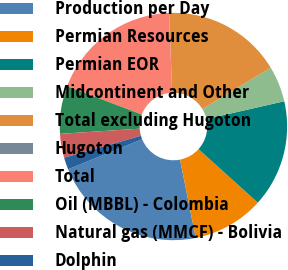<chart> <loc_0><loc_0><loc_500><loc_500><pie_chart><fcel>Production per Day<fcel>Permian Resources<fcel>Permian EOR<fcel>Midcontinent and Other<fcel>Total excluding Hugoton<fcel>Hugoton<fcel>Total<fcel>Oil (MBBL) - Colombia<fcel>Natural gas (MMCF) - Bolivia<fcel>Dolphin<nl><fcel>22.01%<fcel>10.17%<fcel>15.25%<fcel>5.09%<fcel>16.94%<fcel>0.02%<fcel>18.63%<fcel>6.79%<fcel>3.4%<fcel>1.71%<nl></chart> 